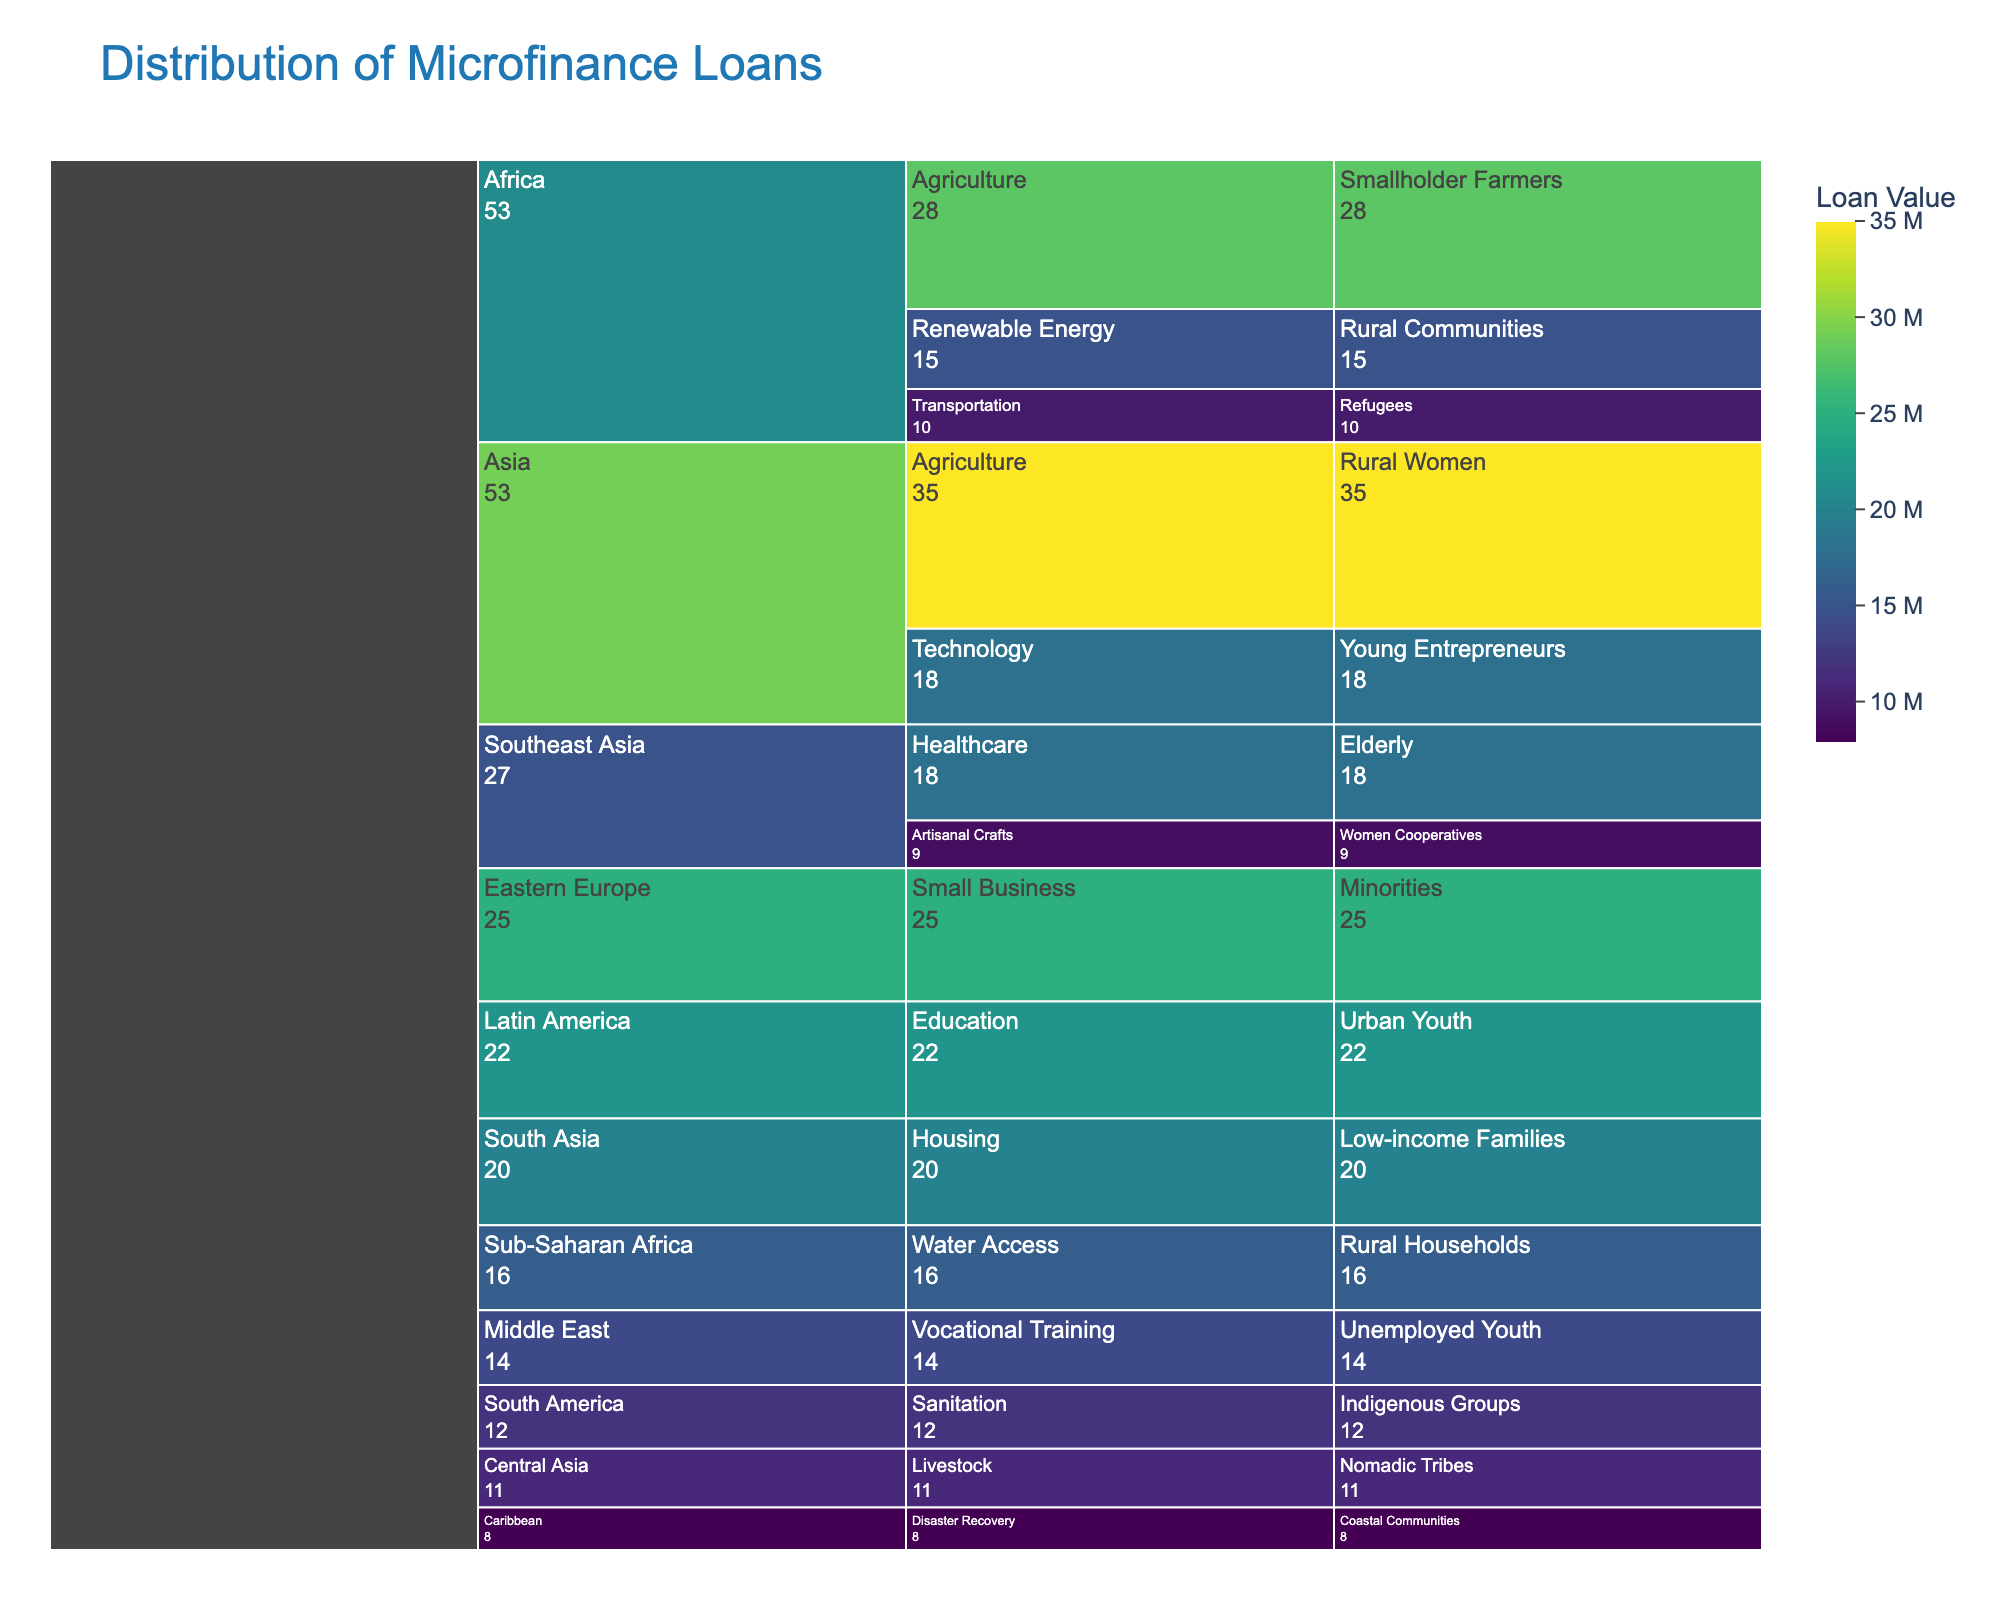what is the title of the icicle chart? The title of the icicle chart is usually displayed at the top of the chart.
Answer: Distribution of Microfinance Loans Which region has the highest loan value for agriculture? Identify all regions with Agriculture loans and compare their values. Asia has 35M, and Africa has 28M.
Answer: Asia How much total loan value is allocated for Urban Youth and Young Entrepreneurs in Asia? Combine the values for Urban Youth (22M) and Young Entrepreneurs (18M) in Asia.
Answer: 40M Which demographic group in Latin America receives microfinance loans? Examine the data branch under Latin America to see which demographic is listed.
Answer: Urban Youth How does the loan value for Small Business in Eastern Europe compare to Housing in South Asia? Compare the values of Small Business in Eastern Europe (25M) and Housing in South Asia (20M).
Answer: Small Business has 5M more Which purpose has the least loan allocation in the Caribbean region? Look under the Caribbean region and see which purpose is listed and its value.
Answer: Disaster Recovery with 8M Which demographic in Sub-Saharan Africa receives microfinance loans, and what is the allocated value? Identify the branch under Sub-Saharan Africa and associated demographic group and value.
Answer: Rural Households, 16M List all regions where Agriculture is a purpose for microfinance loans. Identify all regions with Agriculture as a listed purpose.
Answer: Asia, Africa 